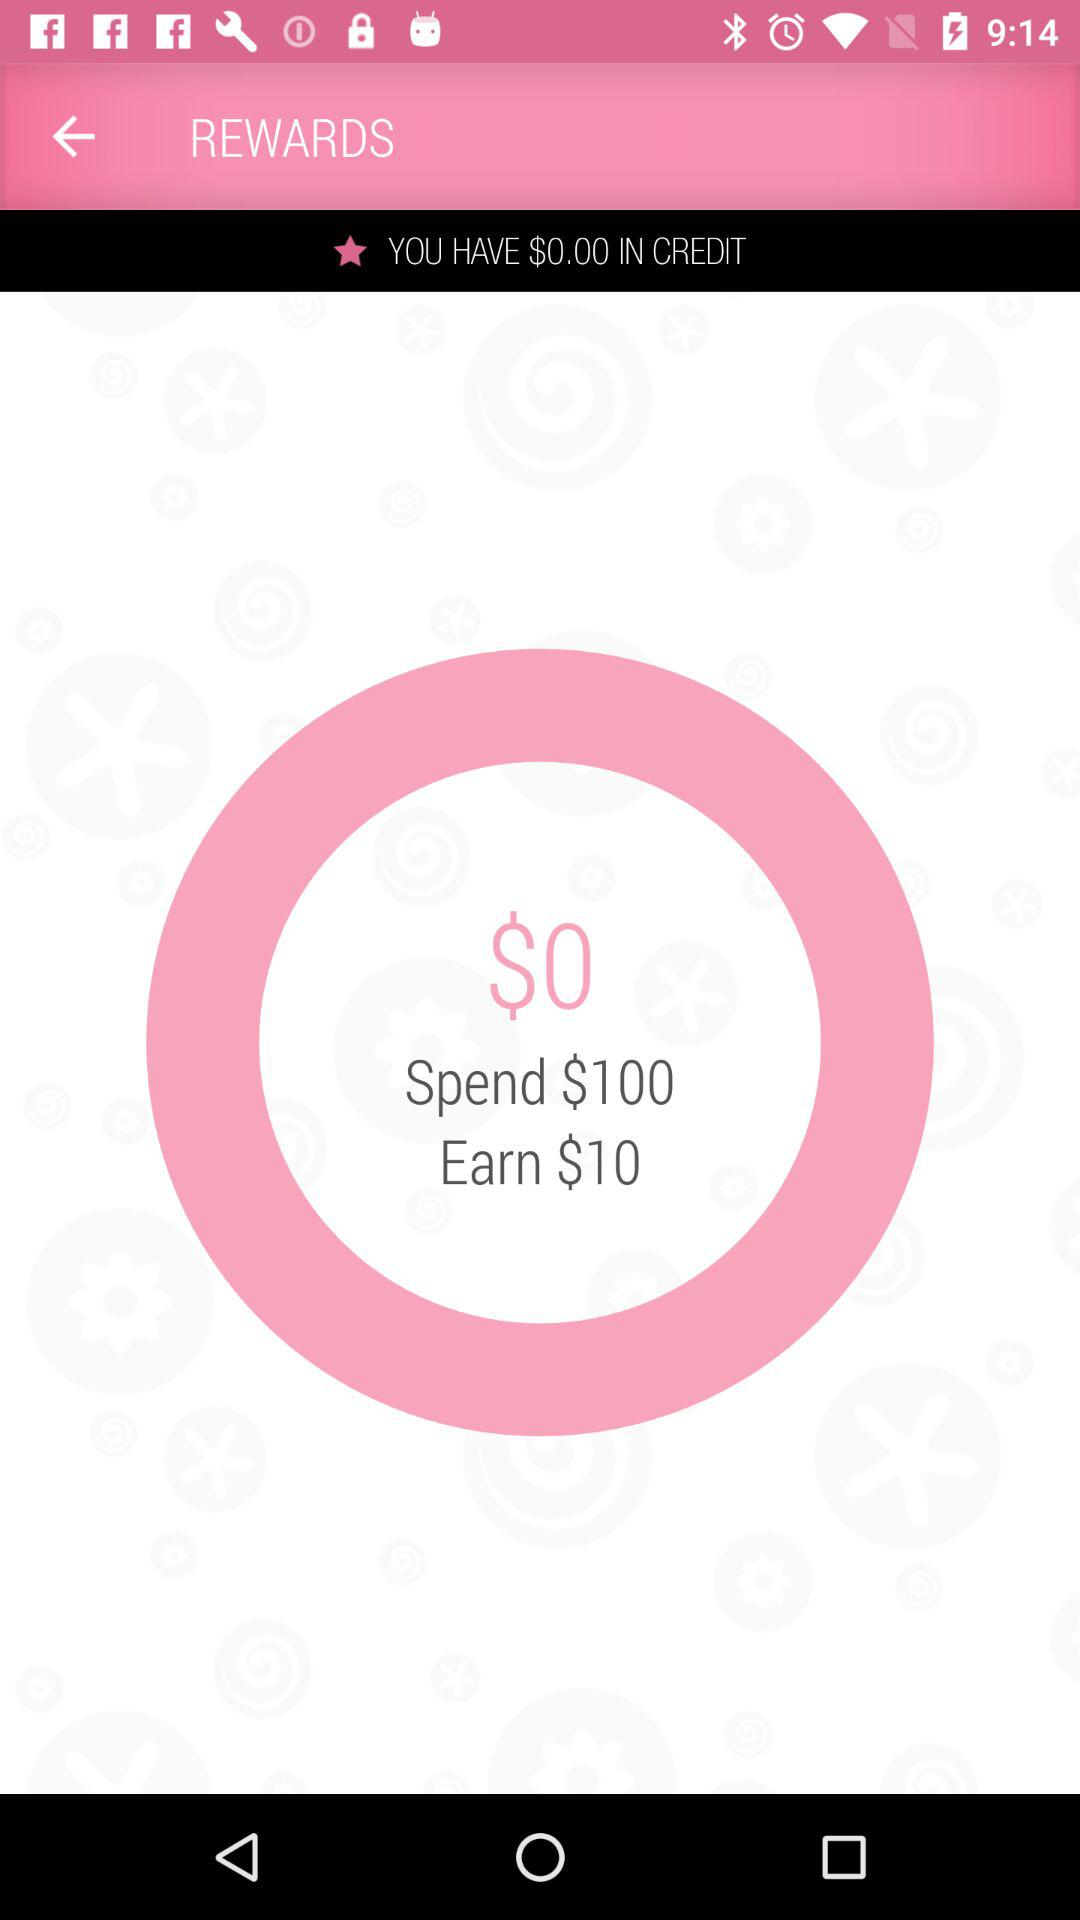What is the amount that I have in my credit? The amount that you have in your credit is $0. 